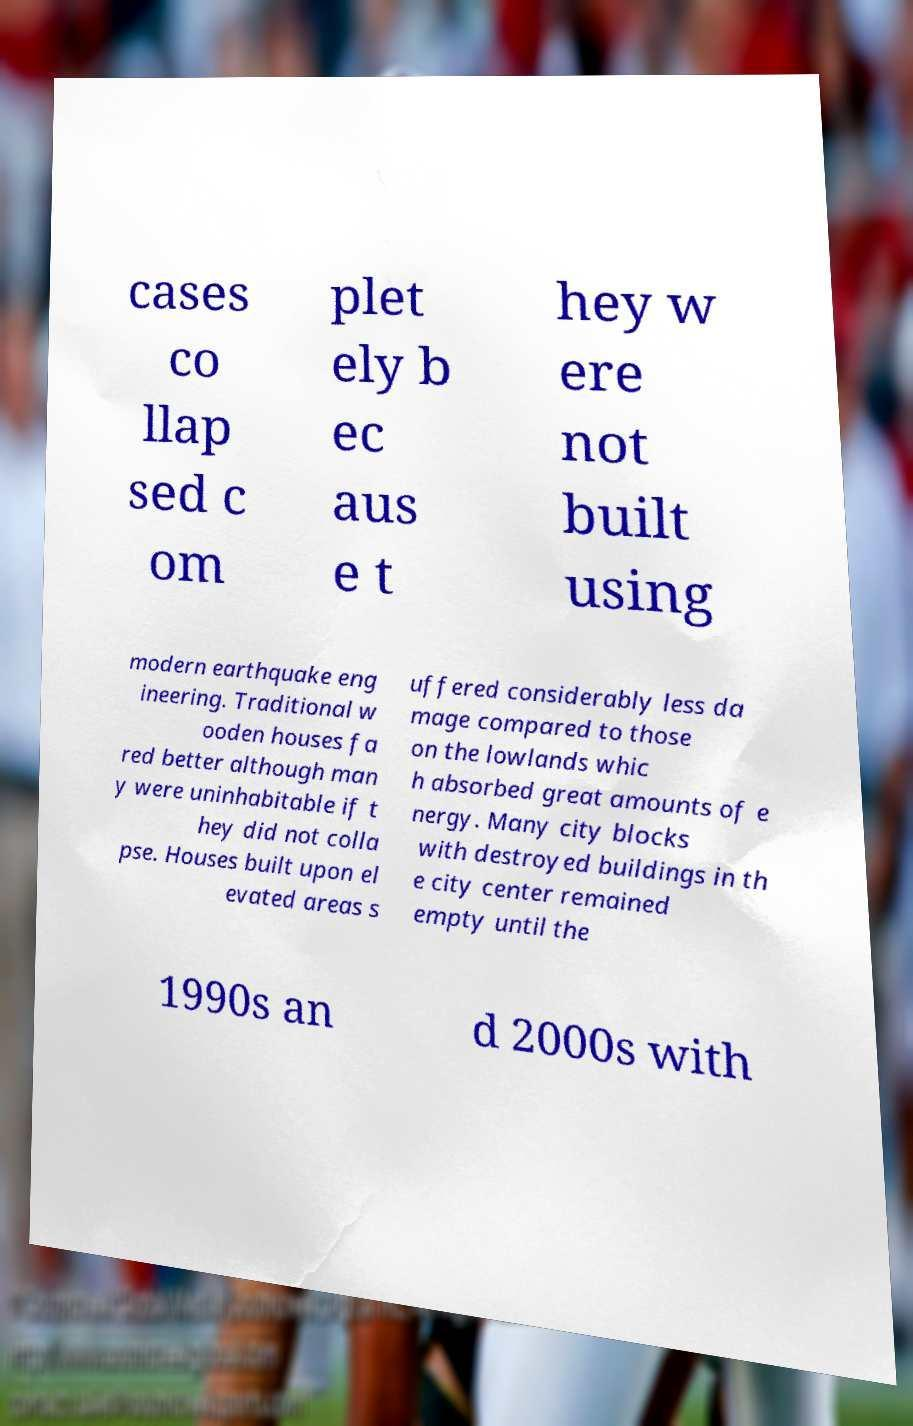For documentation purposes, I need the text within this image transcribed. Could you provide that? cases co llap sed c om plet ely b ec aus e t hey w ere not built using modern earthquake eng ineering. Traditional w ooden houses fa red better although man y were uninhabitable if t hey did not colla pse. Houses built upon el evated areas s uffered considerably less da mage compared to those on the lowlands whic h absorbed great amounts of e nergy. Many city blocks with destroyed buildings in th e city center remained empty until the 1990s an d 2000s with 